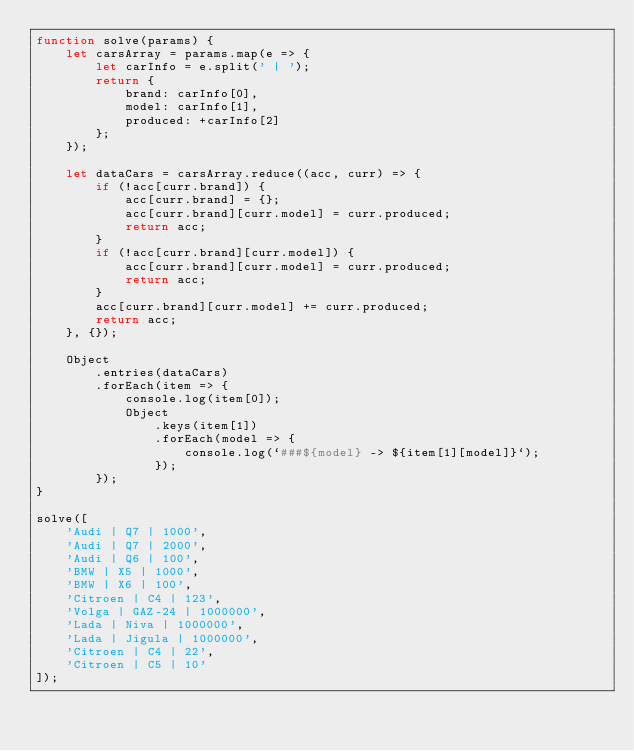<code> <loc_0><loc_0><loc_500><loc_500><_JavaScript_>function solve(params) {
    let carsArray = params.map(e => {
        let carInfo = e.split(' | ');
        return {
            brand: carInfo[0],
            model: carInfo[1],
            produced: +carInfo[2]
        };
    });

    let dataCars = carsArray.reduce((acc, curr) => {
        if (!acc[curr.brand]) {
            acc[curr.brand] = {};
            acc[curr.brand][curr.model] = curr.produced;
            return acc;
        }
        if (!acc[curr.brand][curr.model]) {
            acc[curr.brand][curr.model] = curr.produced;
            return acc;
        }
        acc[curr.brand][curr.model] += curr.produced;
        return acc;
    }, {});

    Object
        .entries(dataCars)
        .forEach(item => {
            console.log(item[0]);
            Object
                .keys(item[1])
                .forEach(model => {
                    console.log(`###${model} -> ${item[1][model]}`);
                });
        });
}

solve([
    'Audi | Q7 | 1000',
    'Audi | Q7 | 2000',
    'Audi | Q6 | 100',
    'BMW | X5 | 1000',
    'BMW | X6 | 100',
    'Citroen | C4 | 123',
    'Volga | GAZ-24 | 1000000',
    'Lada | Niva | 1000000',
    'Lada | Jigula | 1000000',
    'Citroen | C4 | 22',
    'Citroen | C5 | 10'
]);</code> 